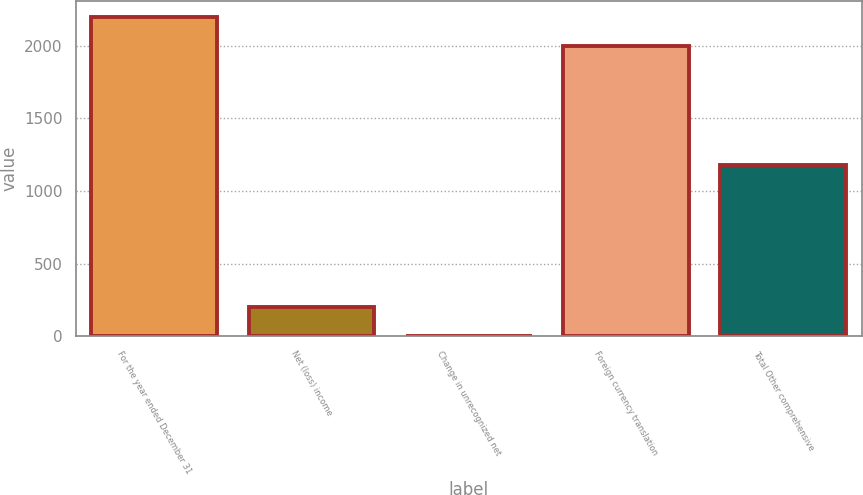Convert chart. <chart><loc_0><loc_0><loc_500><loc_500><bar_chart><fcel>For the year ended December 31<fcel>Net (loss) income<fcel>Change in unrecognized net<fcel>Foreign currency translation<fcel>Total Other comprehensive<nl><fcel>2196.3<fcel>203.3<fcel>2<fcel>1995<fcel>1176<nl></chart> 